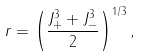<formula> <loc_0><loc_0><loc_500><loc_500>r = \left ( { \frac { J _ { + } ^ { 3 } + J _ { - } ^ { 3 } } { 2 } } \right ) ^ { 1 / 3 } ,</formula> 